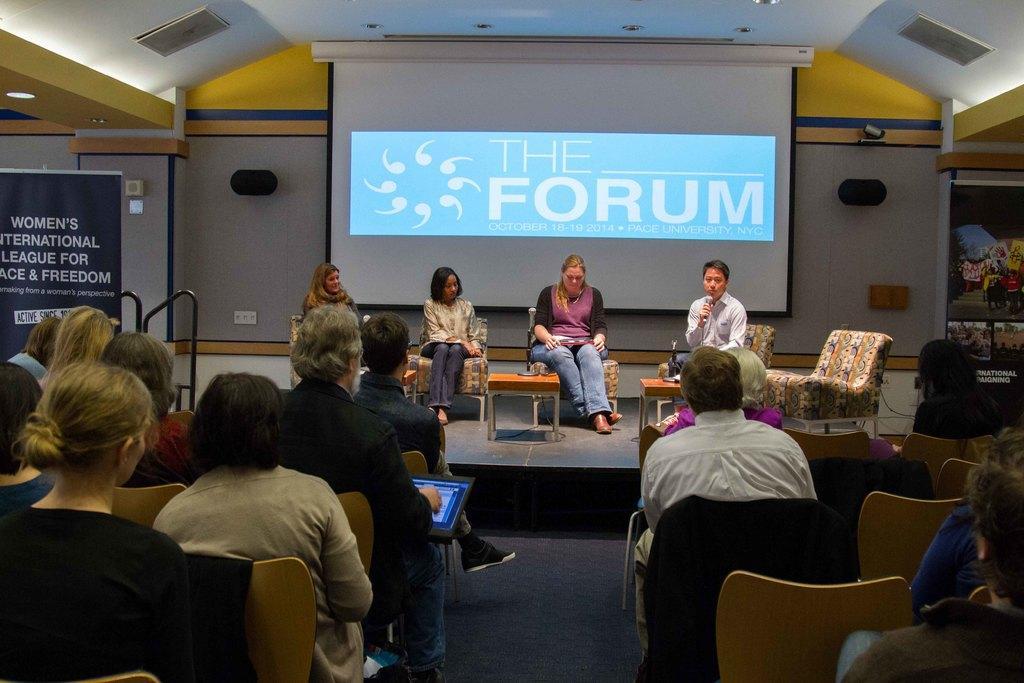Can you describe this image briefly? In this picture we can see a group of people sitting on chairs and a person is holding a laptop and behind the people there is a projector screen. On the left and right side of the projector screen there are banners and there is a ceiling light on the top. 